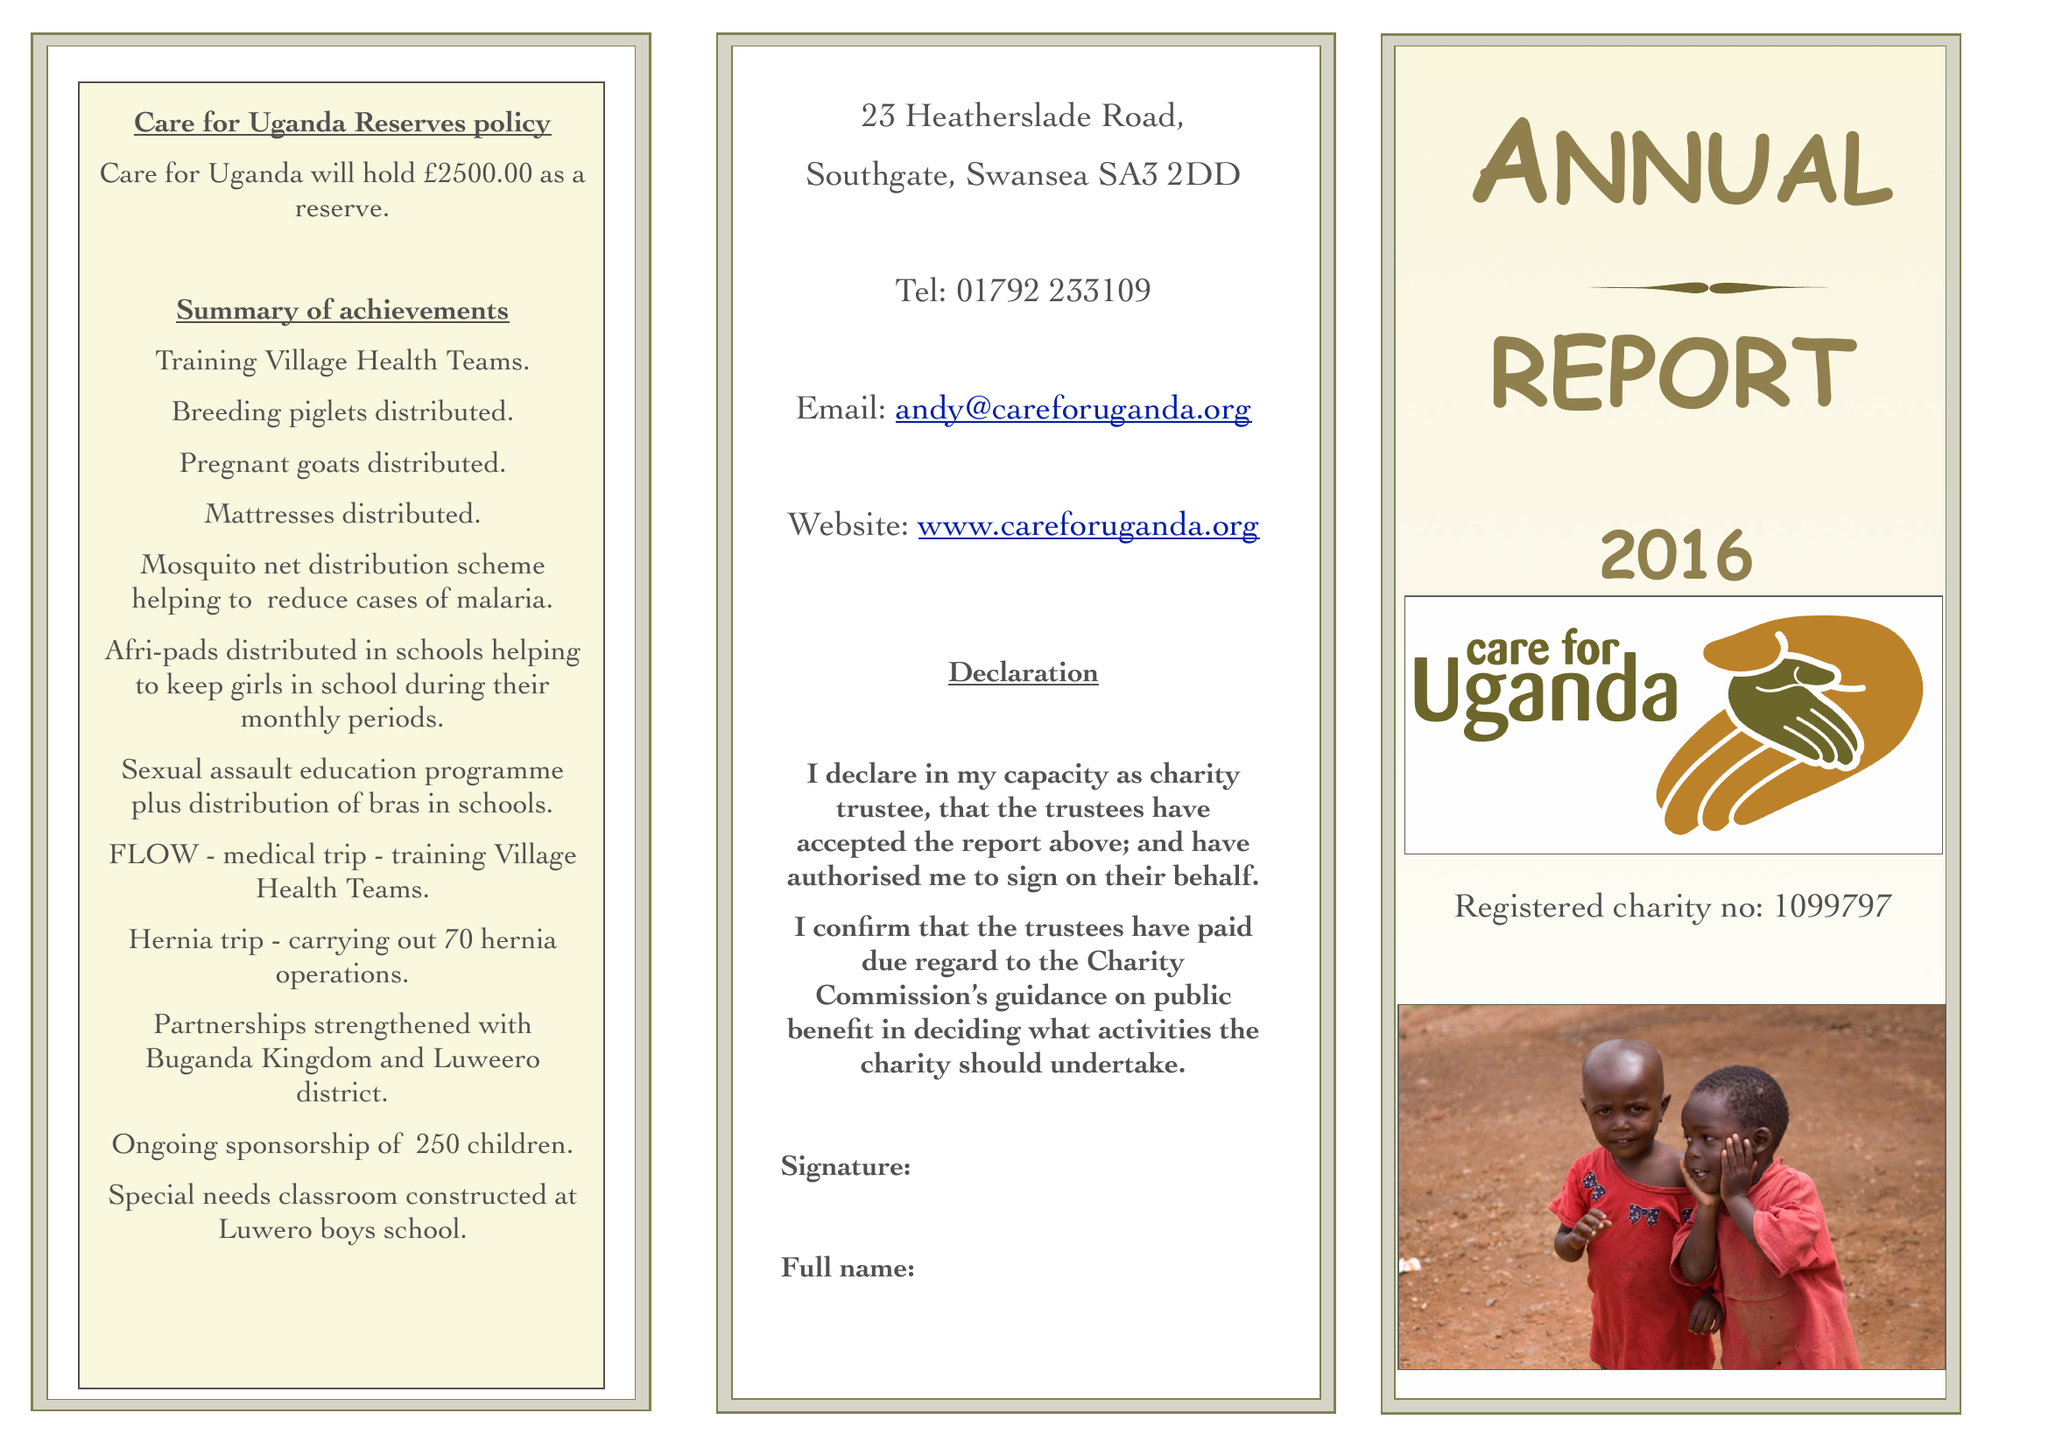What is the value for the address__post_town?
Answer the question using a single word or phrase. SWANSEA 